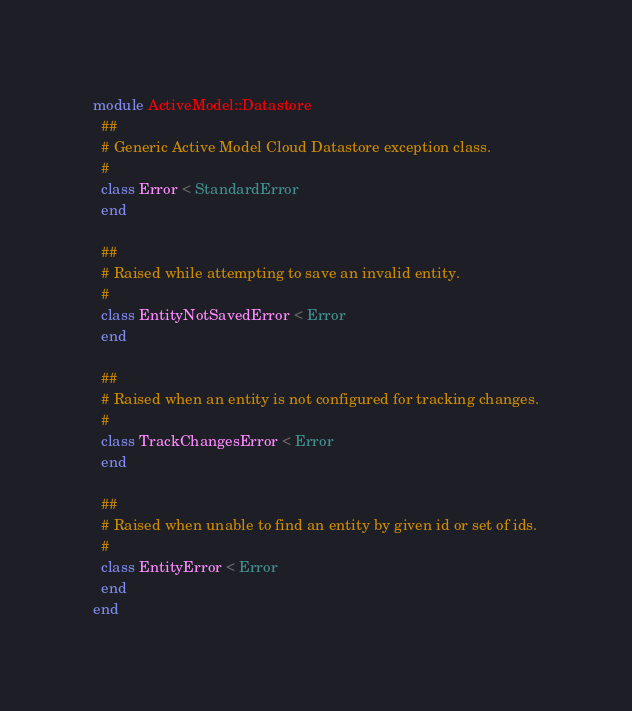<code> <loc_0><loc_0><loc_500><loc_500><_Ruby_>module ActiveModel::Datastore
  ##
  # Generic Active Model Cloud Datastore exception class.
  #
  class Error < StandardError
  end

  ##
  # Raised while attempting to save an invalid entity.
  #
  class EntityNotSavedError < Error
  end

  ##
  # Raised when an entity is not configured for tracking changes.
  #
  class TrackChangesError < Error
  end

  ##
  # Raised when unable to find an entity by given id or set of ids.
  #
  class EntityError < Error
  end
end
</code> 